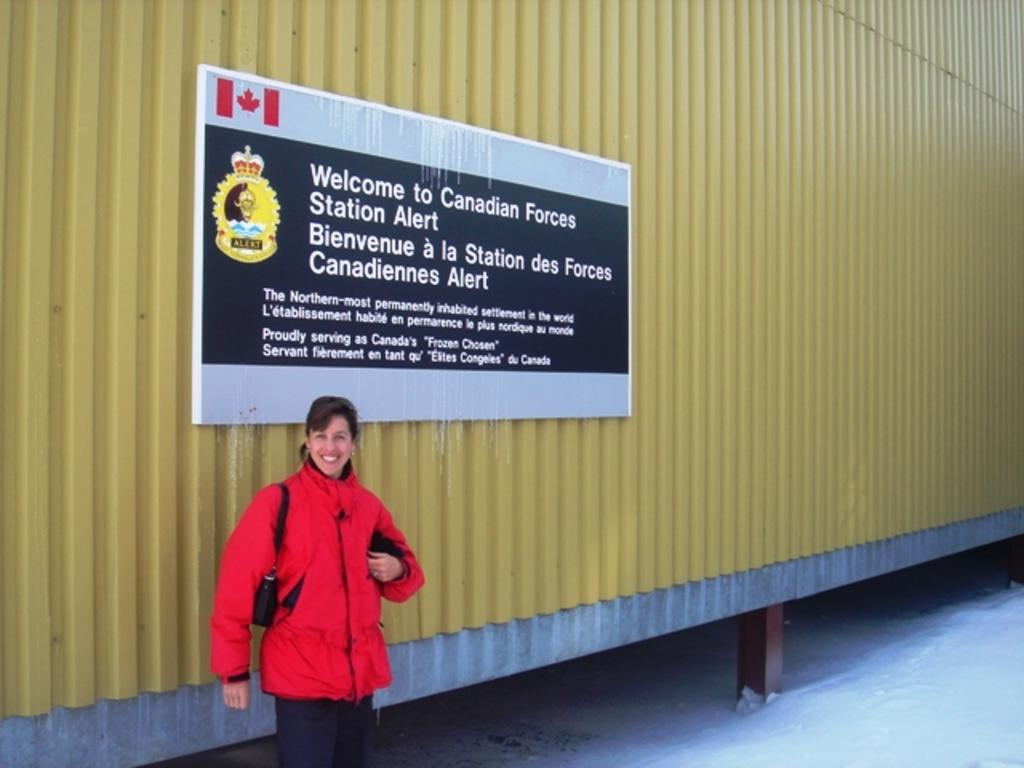What object is present in the image that can hold or store items? There is a container in the image. What is attached to the container, and what does it contain? There is a board attached to the container with logos and text. Who is present in the image, and what is their position? There is a woman in front of the container, and she is standing. How is the woman feeling or expressing herself in the image? The woman is laughing. Are there any fairies flying around the container in the image? There are no fairies present in the image. What type of corn is being grown near the container in the image? There is no corn visible in the image. 